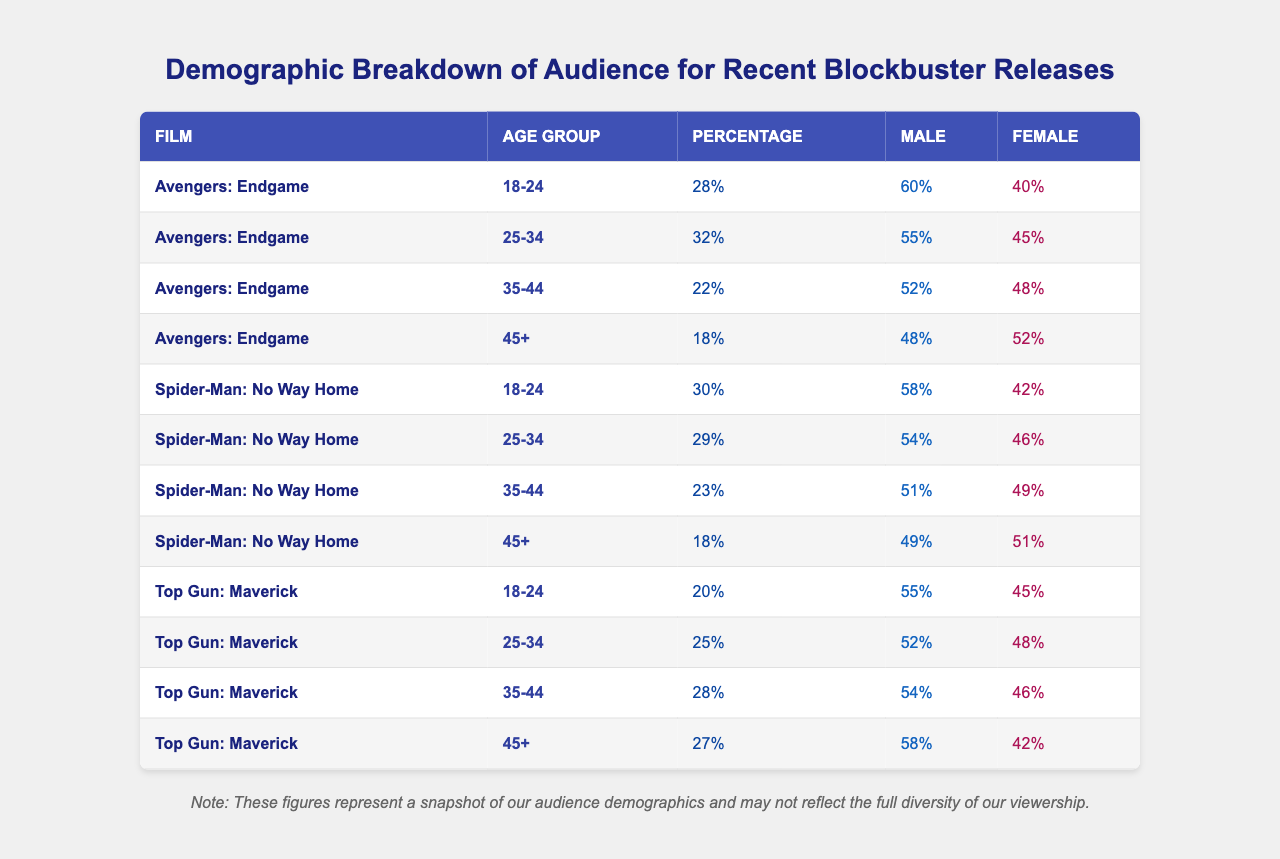What's the percentage of the audience aged 18-24 for "Avengers: Endgame"? In the table under "Avengers: Endgame," the percentage for the age group 18-24 is specified as 28%.
Answer: 28% Which film had the highest percentage of audience aged 25-34? Looking at the percentages for the 25-34 age group, "Avengers: Endgame" has 32%, "Spider-Man: No Way Home" has 29%, and "Top Gun: Maverick" has 25%. Therefore, "Avengers: Endgame" has the highest percentage in this age group.
Answer: Avengers: Endgame What is the total percentage of the audience aged 45+ for "Top Gun: Maverick"? The percentage of the audience aged 45+ for "Top Gun: Maverick" is recorded as 27%.
Answer: 27% Is there a greater percentage of males or females in the 35-44 age group for "Spider-Man: No Way Home"? For "Spider-Man: No Way Home" in the 35-44 age group, males represent 51% and females 49%. Since 51% is greater than 49%, there are more males.
Answer: Males What is the combined percentage of the 45+ age group for "Avengers: Endgame" and "Top Gun: Maverick"? The percentages for the 45+ age group are 18% for "Avengers: Endgame" and 27% for "Top Gun: Maverick." Adding these together gives us 18% + 27% = 45%.
Answer: 45% Which gender has a higher representation in the 45+ age group for "Spider-Man: No Way Home"? For "Spider-Man: No Way Home" in the 45+ age group, males are at 49% and females are at 51%. Since 51% is greater, females have a higher representation.
Answer: Females What is the average percentage of the audience aged 18-24 across all three films? The percentages for the 18-24 age group are 28% for "Avengers: Endgame," 30% for "Spider-Man: No Way Home," and 20% for "Top Gun: Maverick." Summing these gives 28 + 30 + 20 = 78%. Dividing by 3, the average percentage is 78% / 3 = 26%.
Answer: 26% Which age group has the lowest audience percentage for "Top Gun: Maverick"? Examining the age groups for "Top Gun: Maverick," the percentages are 20% for 18-24, 25% for 25-34, 28% for 35-44, and 27% for 45+. The lowest percentage is 20% for the 18-24 age group.
Answer: 18-24 age group Is the percentage of males in the 25-34 age group for "Top Gun: Maverick" greater than 50%? In the 25-34 age group for "Top Gun: Maverick," males represent 52%. Since 52% is greater than 50%, the answer is yes.
Answer: Yes What is the percentage difference in the audience for the 35-44 age group between "Avengers: Endgame" and "Top Gun: Maverick"? "Avengers: Endgame" has 22% and "Top Gun: Maverick" has 28% for the 35-44 age group. The difference is calculated as 28% - 22% = 6%.
Answer: 6% 